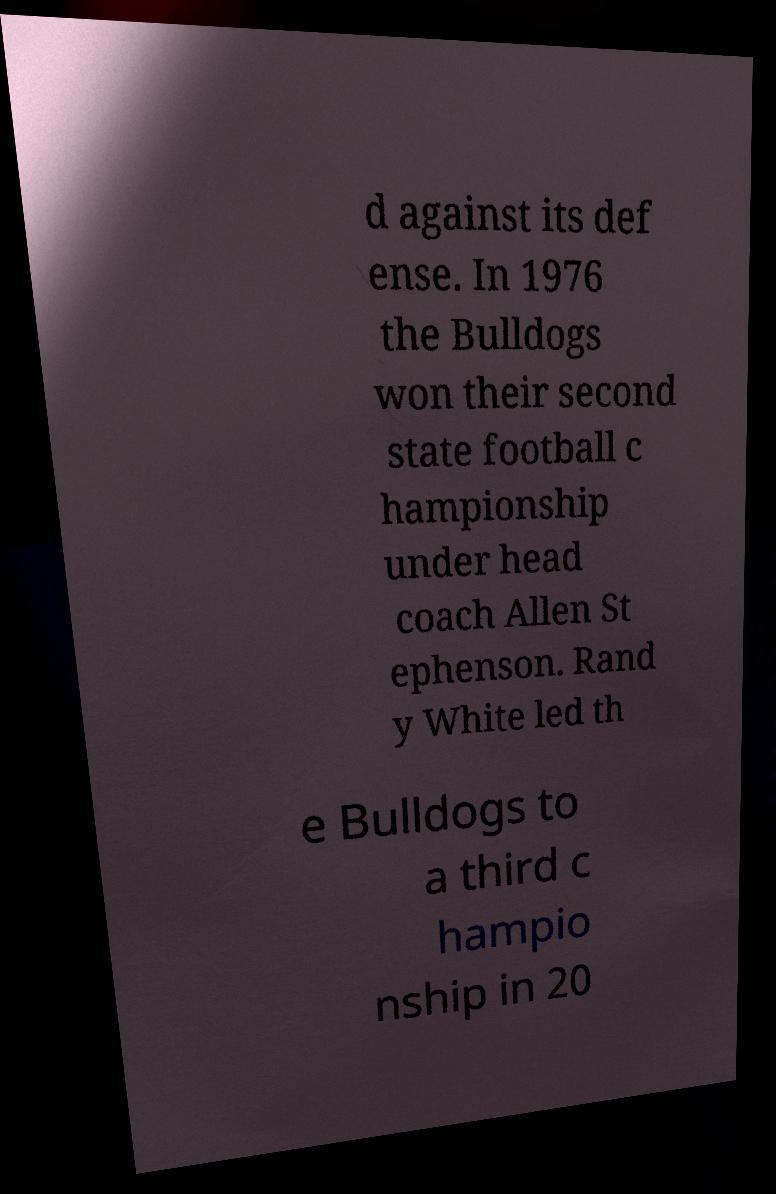For documentation purposes, I need the text within this image transcribed. Could you provide that? d against its def ense. In 1976 the Bulldogs won their second state football c hampionship under head coach Allen St ephenson. Rand y White led th e Bulldogs to a third c hampio nship in 20 